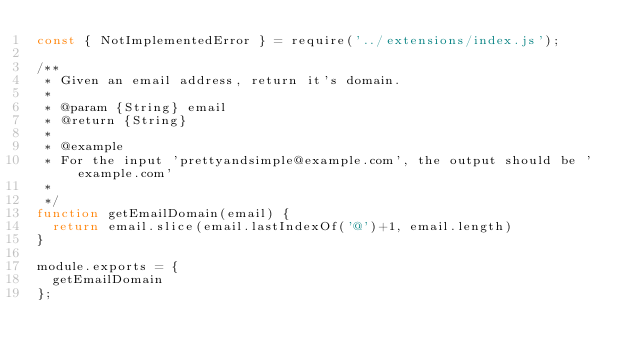<code> <loc_0><loc_0><loc_500><loc_500><_JavaScript_>const { NotImplementedError } = require('../extensions/index.js');

/**
 * Given an email address, return it's domain.
 *
 * @param {String} email
 * @return {String}
 *
 * @example
 * For the input 'prettyandsimple@example.com', the output should be 'example.com'
 *
 */
function getEmailDomain(email) {
  return email.slice(email.lastIndexOf('@')+1, email.length)
}

module.exports = {
  getEmailDomain
};
</code> 